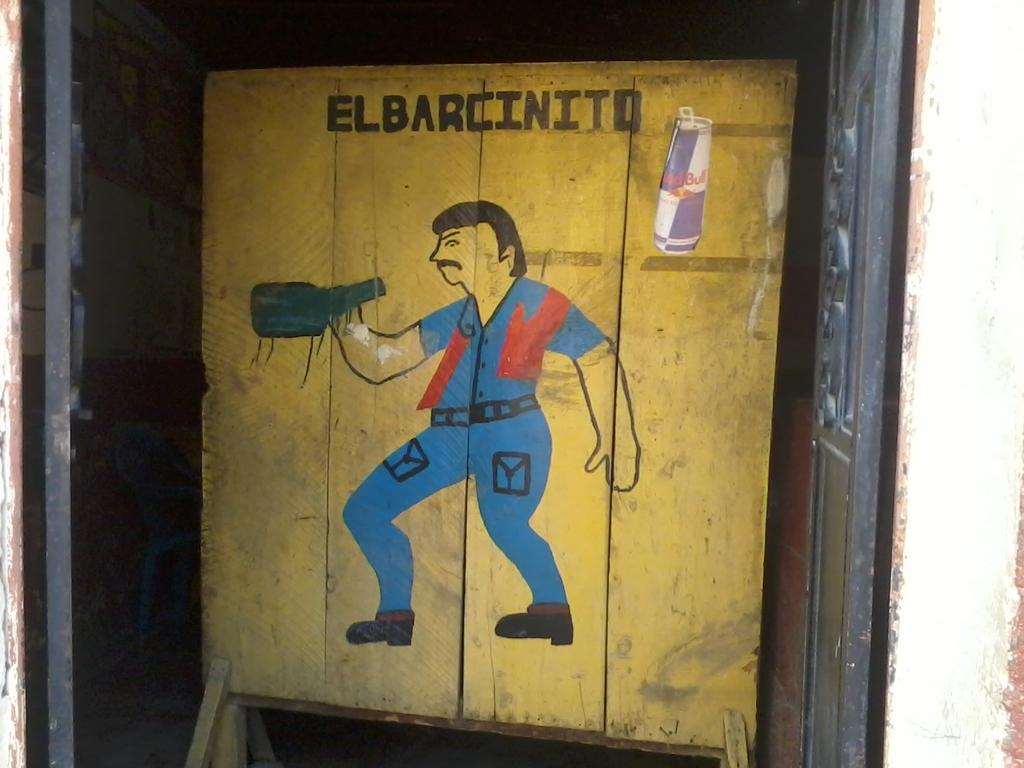<image>
Summarize the visual content of the image. A cartoon depiction of man drinking from a blue bottle with a Red Bull can in the upper right corner. 